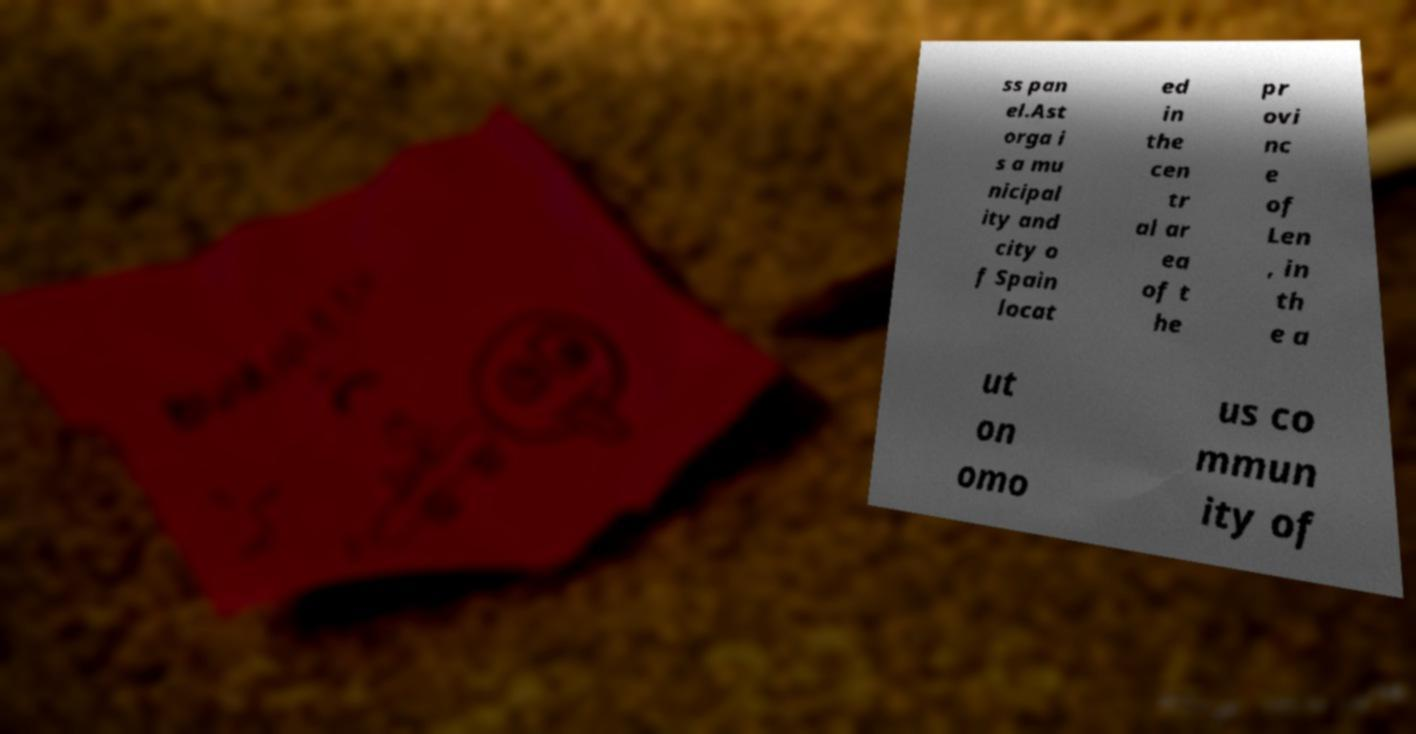Please identify and transcribe the text found in this image. ss pan el.Ast orga i s a mu nicipal ity and city o f Spain locat ed in the cen tr al ar ea of t he pr ovi nc e of Len , in th e a ut on omo us co mmun ity of 